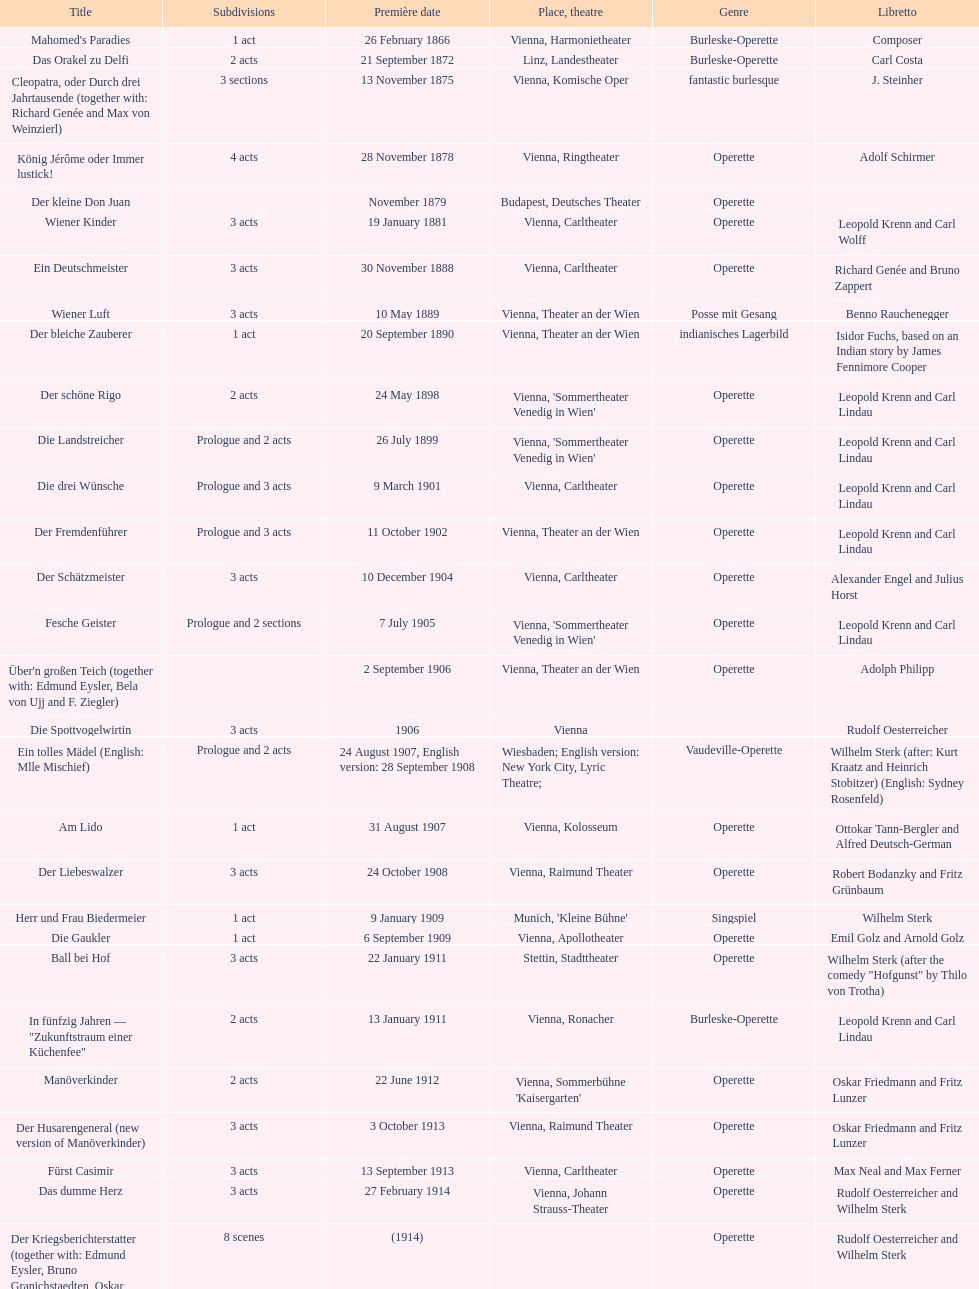What year marked the release of his most recent operetta? 1930. 